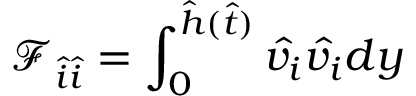Convert formula to latex. <formula><loc_0><loc_0><loc_500><loc_500>\mathcal { F } _ { \hat { i } \hat { i } } = \int _ { 0 } ^ { \hat { h } ( \hat { t } ) } \hat { v _ { i } } \hat { v _ { i } } d y</formula> 